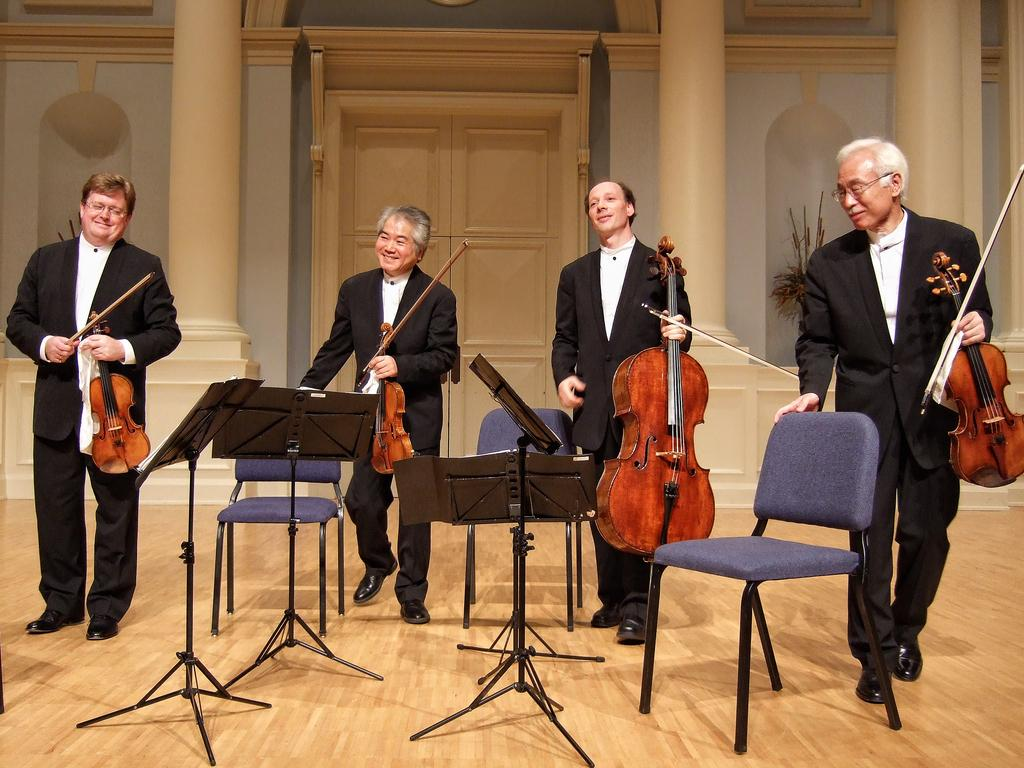How many people are present in the image? There are four people in the image. What are the people holding in the image? The people are holding violins of different sizes. How many chairs are visible in the image? There are three chairs in the image. What type of flooring is present in the image? There is a wooden floor in the image. What type of wool is being used to make the camp in the image? There is no camp or wool present in the image; it features four people holding violins of different sizes, with three chairs and a wooden floor. 